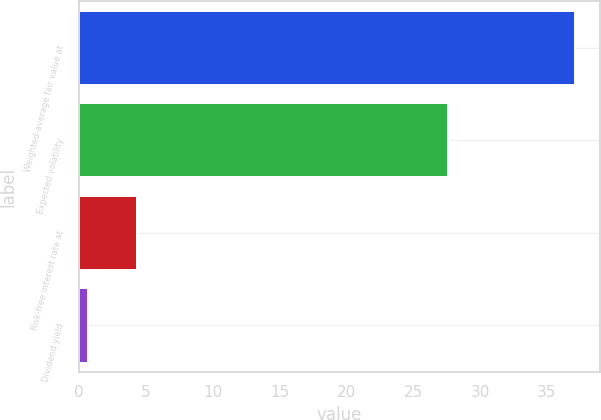<chart> <loc_0><loc_0><loc_500><loc_500><bar_chart><fcel>Weighted-average fair value at<fcel>Expected volatility<fcel>Risk-free interest rate at<fcel>Dividend yield<nl><fcel>37.12<fcel>27.6<fcel>4.34<fcel>0.7<nl></chart> 